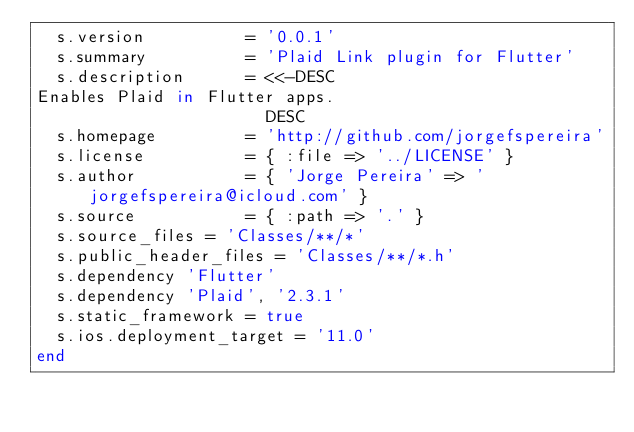<code> <loc_0><loc_0><loc_500><loc_500><_Ruby_>  s.version          = '0.0.1'
  s.summary          = 'Plaid Link plugin for Flutter'
  s.description      = <<-DESC
Enables Plaid in Flutter apps.
                       DESC
  s.homepage         = 'http://github.com/jorgefspereira'
  s.license          = { :file => '../LICENSE' }
  s.author           = { 'Jorge Pereira' => 'jorgefspereira@icloud.com' }
  s.source           = { :path => '.' }
  s.source_files = 'Classes/**/*'
  s.public_header_files = 'Classes/**/*.h'
  s.dependency 'Flutter'
  s.dependency 'Plaid', '2.3.1'
  s.static_framework = true
  s.ios.deployment_target = '11.0'
end

</code> 